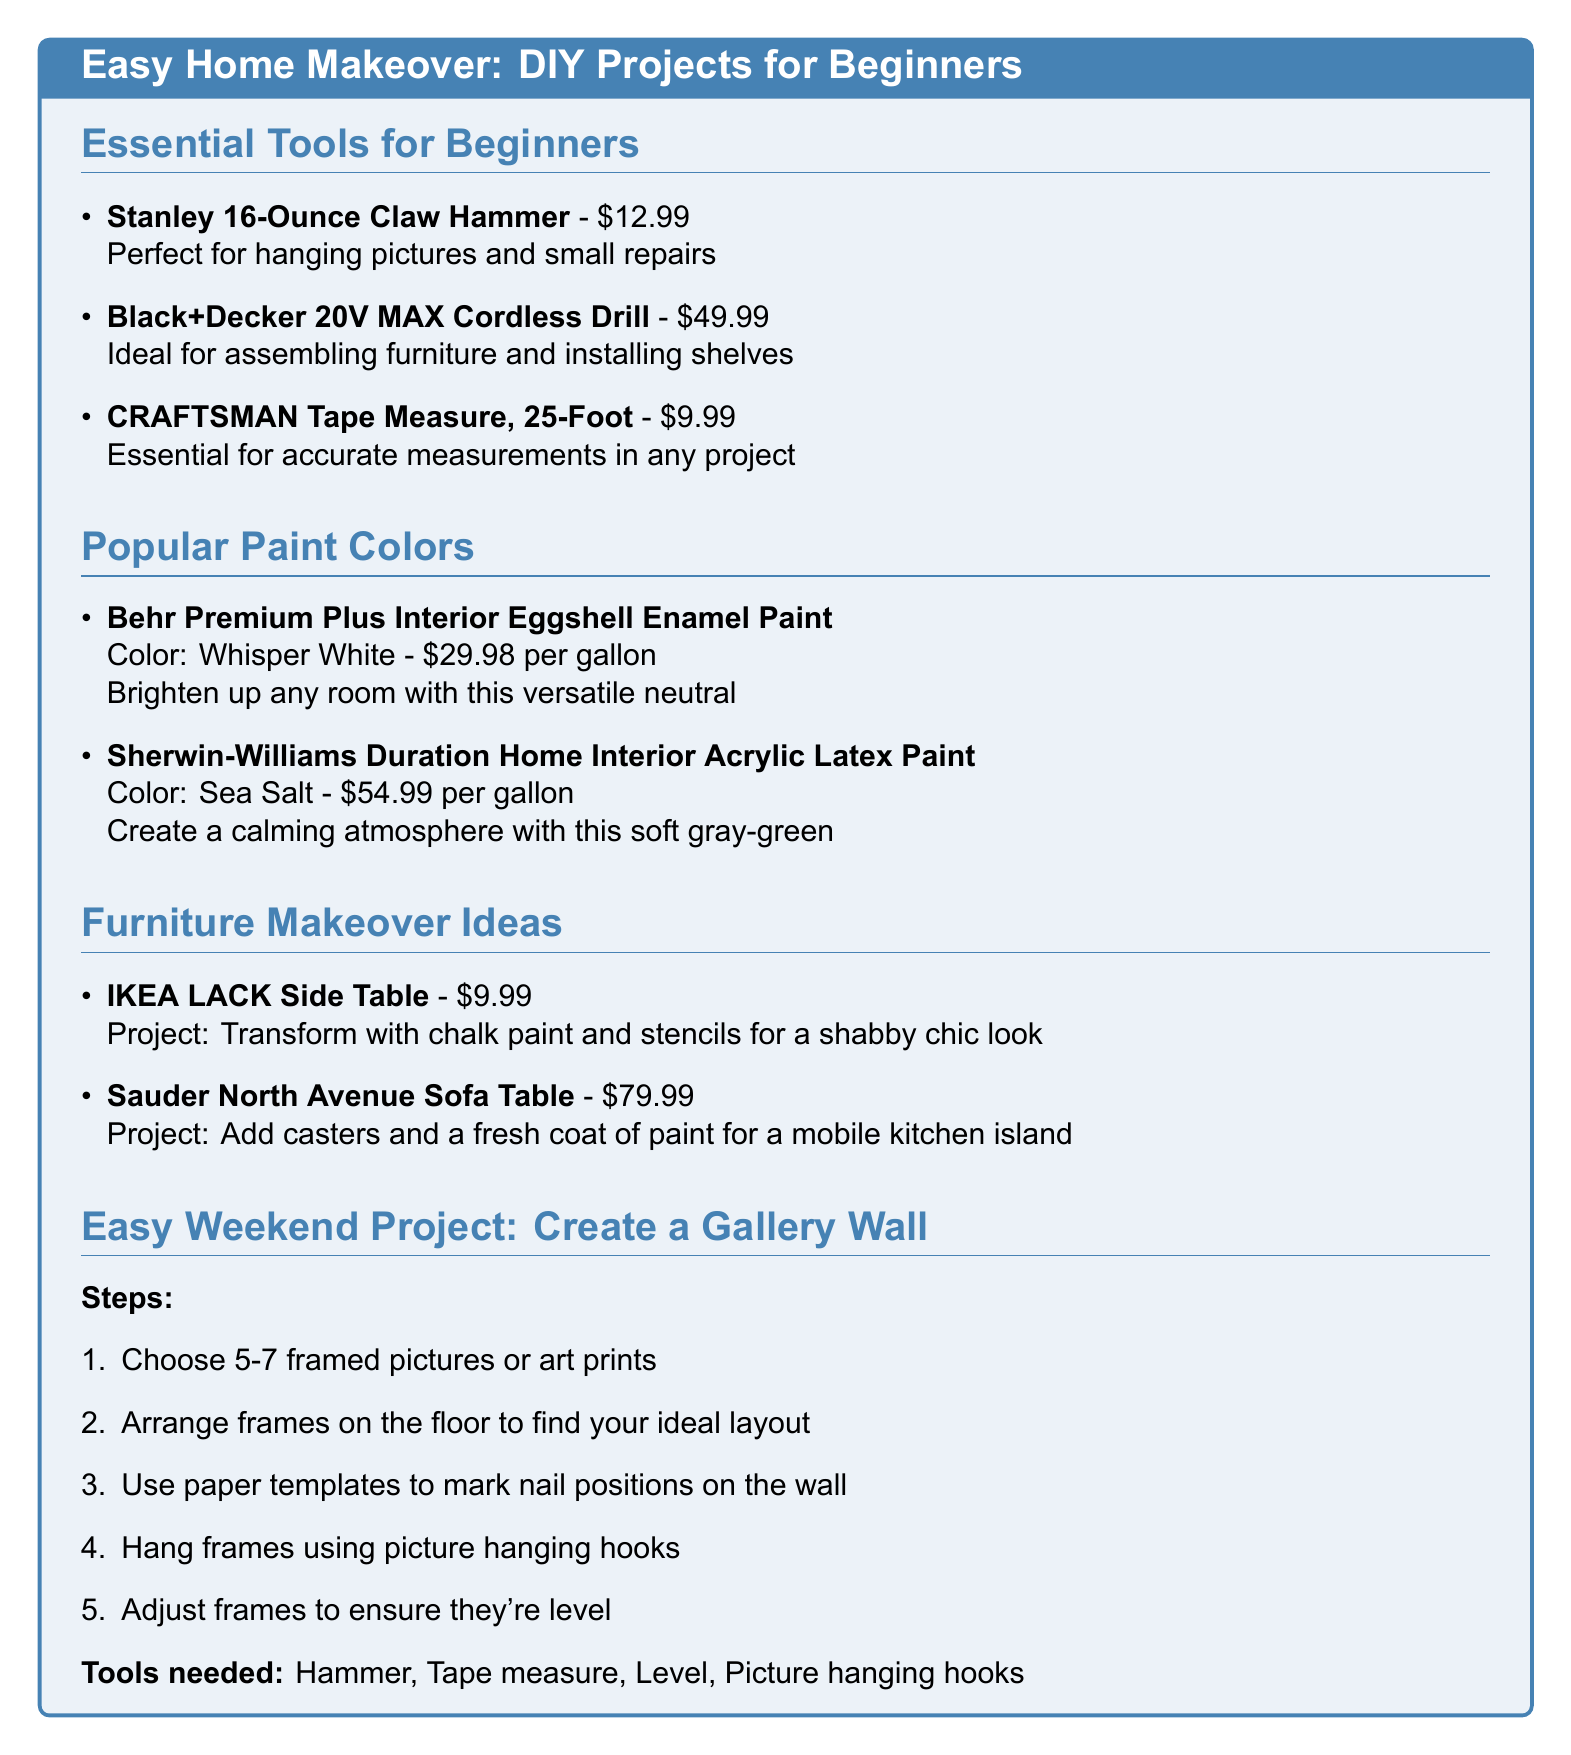What is the price of the Stanley 16-Ounce Claw Hammer? The price is stated in the document next to the tool name.
Answer: $12.99 What is the color of the Behr Premium Plus paint? The color is specified next to the paint name in the document.
Answer: Whisper White What project idea is suggested for the IKEA LACK Side Table? The project idea is described under the furniture section alongside the item name.
Answer: Transform with chalk paint and stencils for a shabby chic look How many pictures should you choose for the gallery wall? The number is provided in the project section of the document.
Answer: 5-7 What tool is needed to hang frames in the gallery wall project? The tools required are listed at the end of the gallery wall section.
Answer: Hammer What is the price of the Black+Decker Cordless Drill? The price is mentioned next to the tool in the essential tools section.
Answer: $49.99 What is the main color of the Sherwin-Williams paint? The color is specified next to the product's name in the document.
Answer: Sea Salt How many steps are listed for creating a gallery wall? The number of steps can be counted from the project list in the document.
Answer: 5 